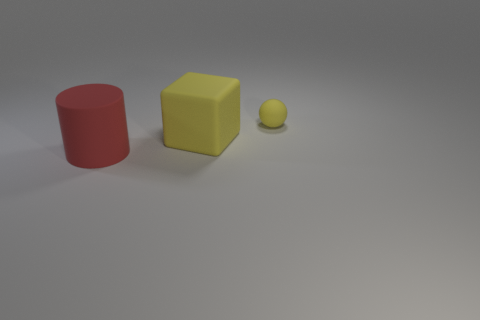Add 1 cylinders. How many objects exist? 4 Subtract all spheres. How many objects are left? 2 Add 1 large yellow rubber things. How many large yellow rubber things exist? 2 Subtract 0 blue cylinders. How many objects are left? 3 Subtract all small yellow objects. Subtract all red cylinders. How many objects are left? 1 Add 2 cylinders. How many cylinders are left? 3 